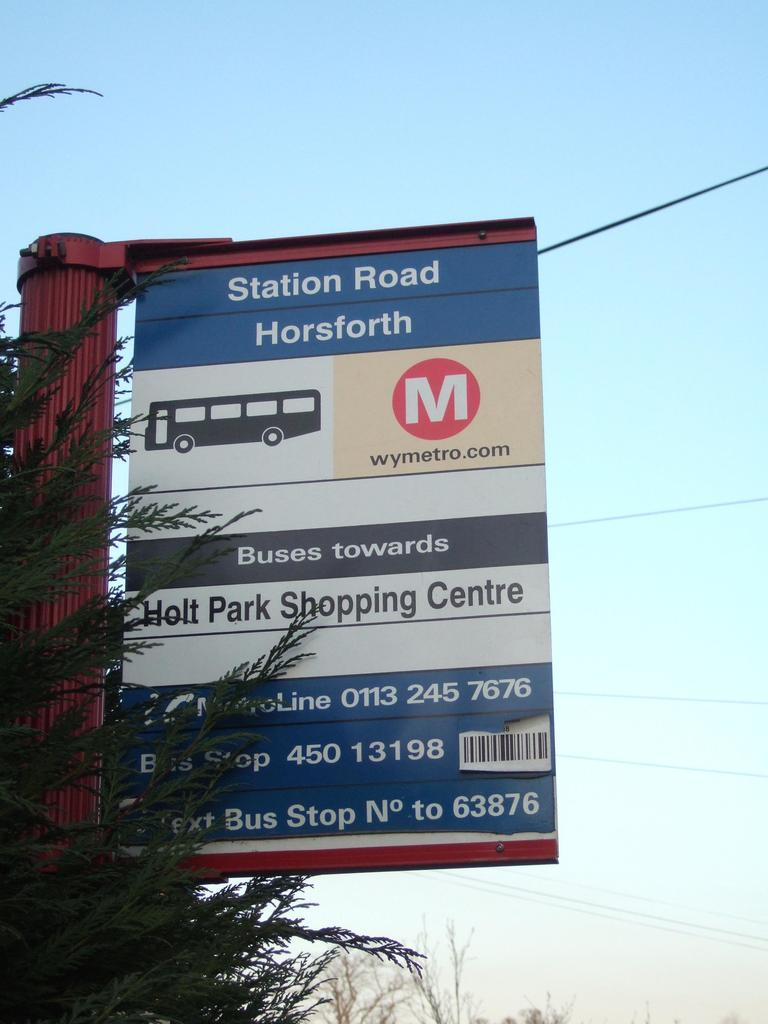<image>
Offer a succinct explanation of the picture presented. a sign that has the words Station Road on the front 